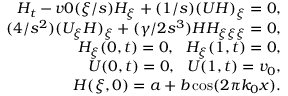Convert formula to latex. <formula><loc_0><loc_0><loc_500><loc_500>\begin{array} { r } { H _ { t } - v 0 ( \xi / s ) H _ { \xi } + ( 1 / s ) ( U H ) _ { \xi } = 0 , } \\ { ( 4 / s ^ { 2 } ) ( U _ { \xi } H ) _ { \xi } + ( \gamma / 2 s ^ { 3 } ) H H _ { \xi \xi \xi } = 0 , } \\ { H _ { \xi } ( 0 , t ) = 0 , \ \ H _ { \xi } ( 1 , t ) = 0 , } \\ { U ( 0 , t ) = 0 , \ \ U ( 1 , t ) = v _ { 0 } , } \\ { H ( \xi , 0 ) = a + b \cos ( 2 \pi k _ { 0 } x ) . } \end{array}</formula> 